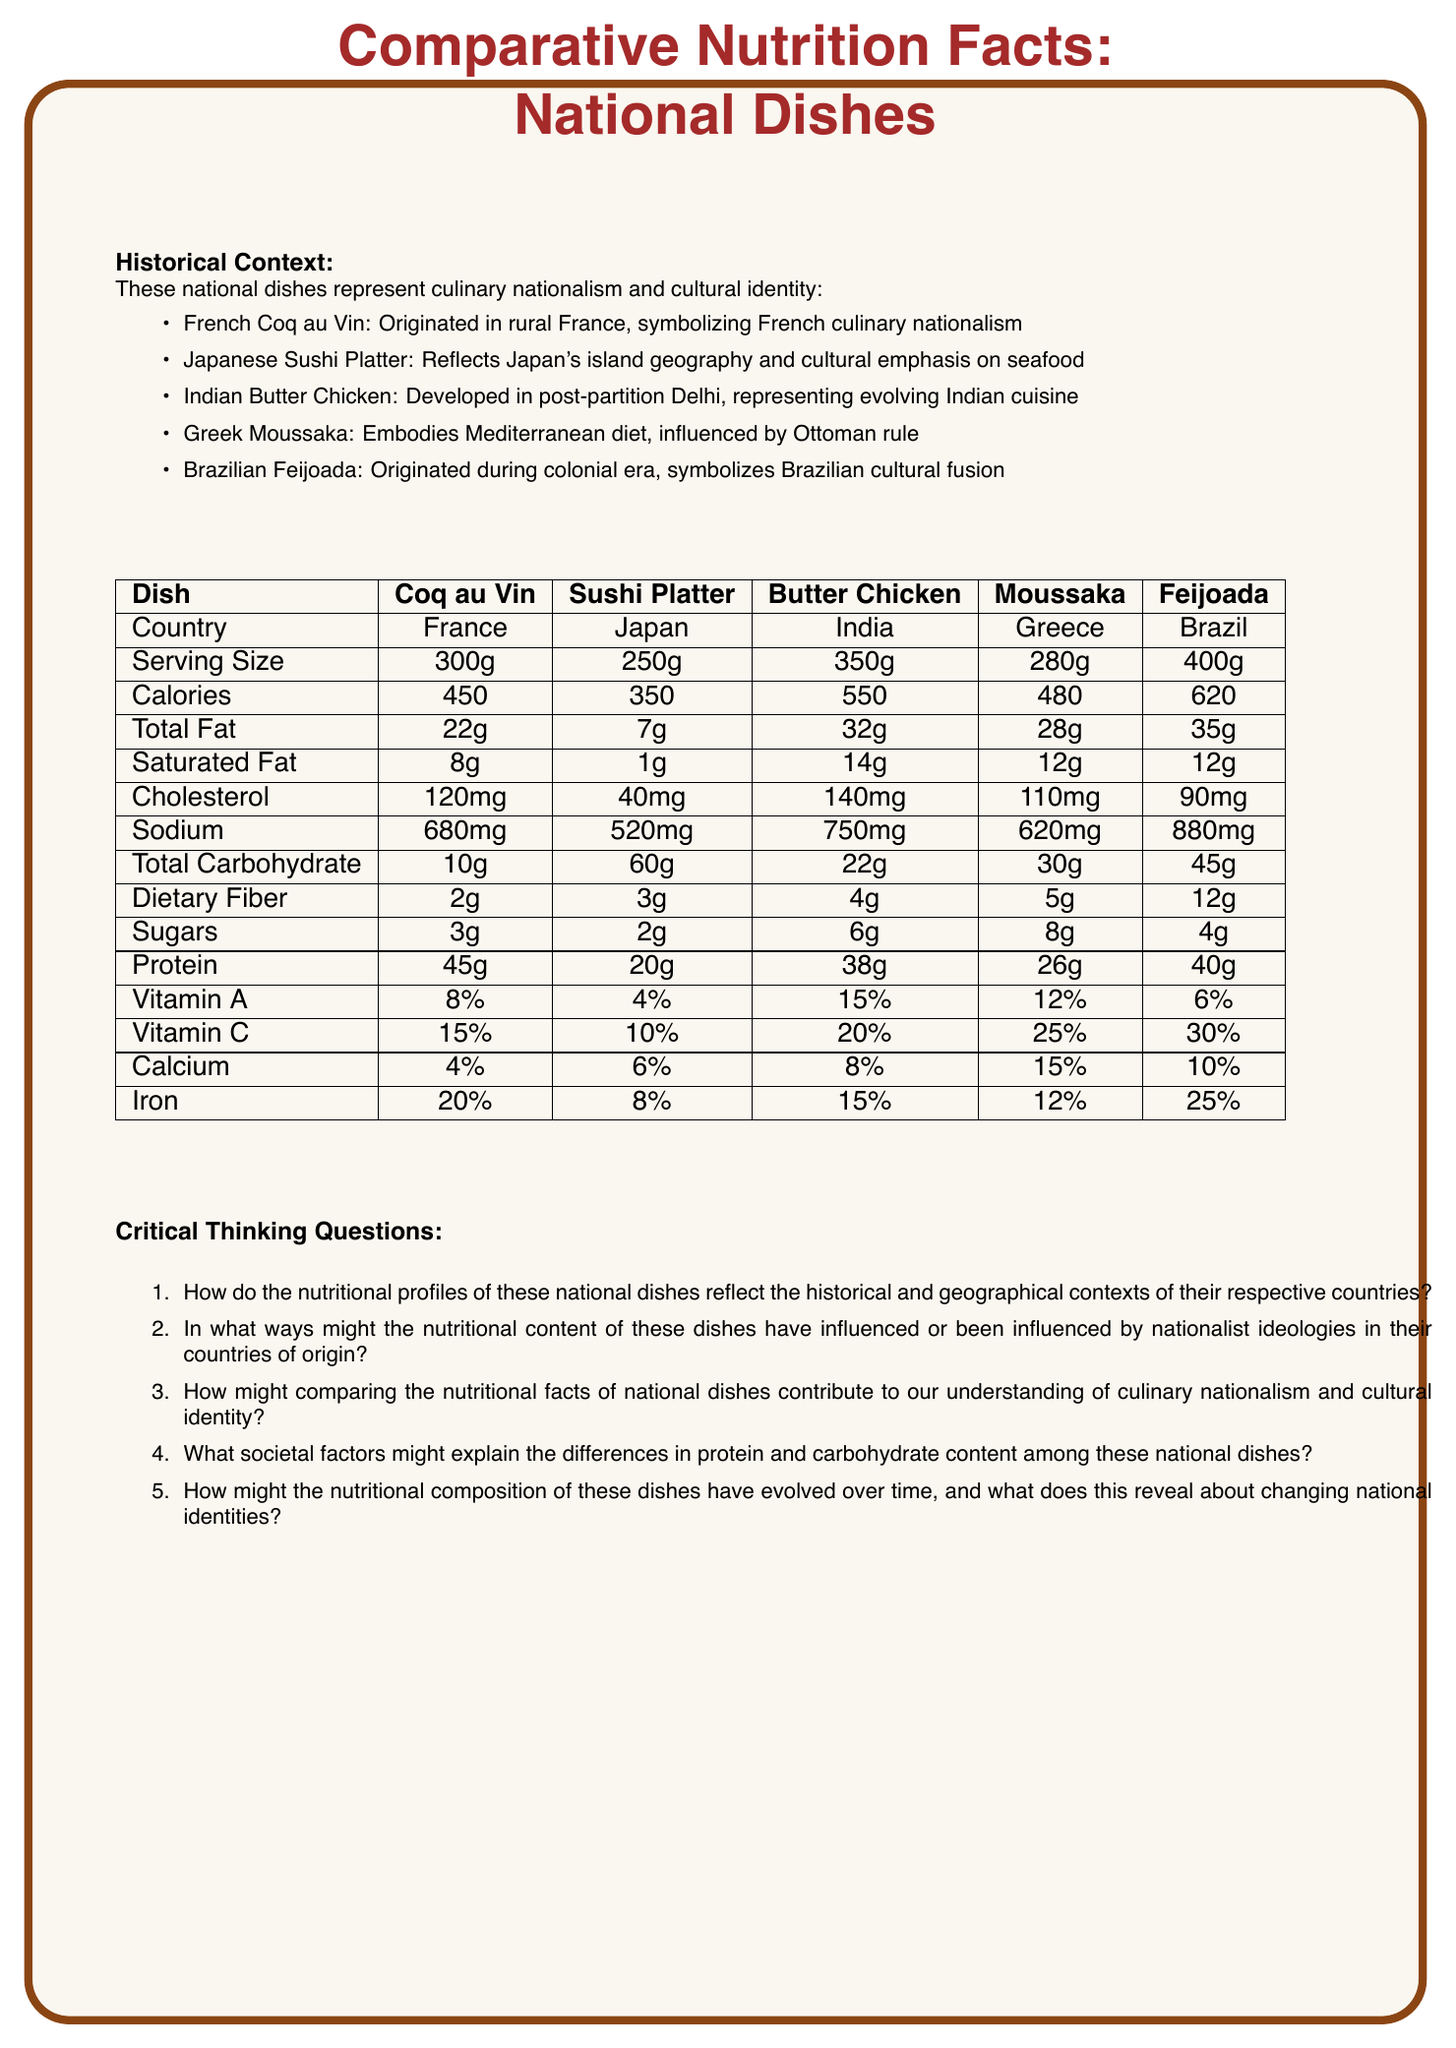What is the serving size for Brazilian Feijoada? The document lists Brazilian Feijoada's serving size as 400g.
Answer: 400g Which dish has the highest calorie content? A. Coq au Vin B. Sushi Platter C. Butter Chicken D. Moussaka E. Feijoada Feijoada has the highest calorie content at 620 calories per serving, as indicated in the table.
Answer: E What is the saturated fat content of Greek Moussaka? The table shows that Greek Moussaka contains 12g of saturated fat.
Answer: 12g True or False: The Japanese Sushi Platter has the highest protein content among the dishes listed. The Japanese Sushi Platter contains 20g of protein, while other dishes such as Coq au Vin, Butter Chicken, and Feijoada have higher protein contents (45g, 38g, and 40g respectively).
Answer: False Describe the main idea of the document. This document aims to provide a comparative analysis of the nutritional profiles of national dishes from France, Japan, India, Greece, and Brazil, along with their historical contexts, highlighting culinary nationalism and cultural identity.
Answer: The document compares the nutritional facts of traditional national dishes from different countries, emphasizing their historical contexts and cultural significance. It includes a table listing various nutrition metrics for each dish and critical thinking questions to analyze how these factors reflect nationalist ideologies and cultural identities. Which dish has the lowest sodium content? The table lists the sodium content of the Japanese Sushi Platter as 520mg, which is the lowest among the dishes.
Answer: Japanese Sushi Platter How much dietary fiber does Indian Butter Chicken contain? According to the table, Indian Butter Chicken has 4g of dietary fiber.
Answer: 4g Which of these dishes provides the highest percentage of daily iron intake? A. Coq au Vin B. Sushi Platter C. Butter Chicken D. Moussaka E. Feijoada Feijoada provides 25% of the daily iron intake, the highest among the dishes listed.
Answer: E What does the historical context of Brazilian Feijoada symbolize? The historical context for Brazilian Feijoada specifies that it symbolizes Brazilian cultural fusion originating during the colonial era.
Answer: Brazilian cultural fusion Identify one dish that reflects Japan's island geography and cultural emphasis on seafood. According to the historical contexts provided, the Japanese Sushi Platter reflects Japan's island geography and cultural emphasis on seafood.
Answer: Japanese Sushi Platter Which dish has the highest saturated fat content? The table indicates that Indian Butter Chicken has the highest saturated fat content at 14g.
Answer: Indian Butter Chicken What factors might explain the high carbohydrate content in Japanese Sushi Platter compared to the other dishes? The document provides nutritional facts but does not elaborate on the specific cultural, historical, or culinary reasons that contribute to the high carbohydrate content in the Sushi Platter.
Answer: Not enough information What is the percentage of Vitamin C in Greek Moussaka? The table lists Greek Moussaka as containing 25% of the daily recommended Vitamin C intake.
Answer: 25% How would analyzing these nutritional facts help in understanding the concept of culinary nationalism and cultural identity? By comparing the differences in nutritional content and their historical contexts, one can gain insight into how each nation's dietary habits are shaped by their environment and history, contributing to a sense of cultural identity and nationalism through food.
Answer: Analyzing the nutritional facts of national dishes can reveal how historical and geographical contexts influence dietary habits, which in turn reflect nationalist ideologies and cultural identities. For example, the use of local ingredients and traditional cooking methods can highlight the cultural roots and uniqueness of each dish, contributing to a broader understanding of culinary nationalism. 